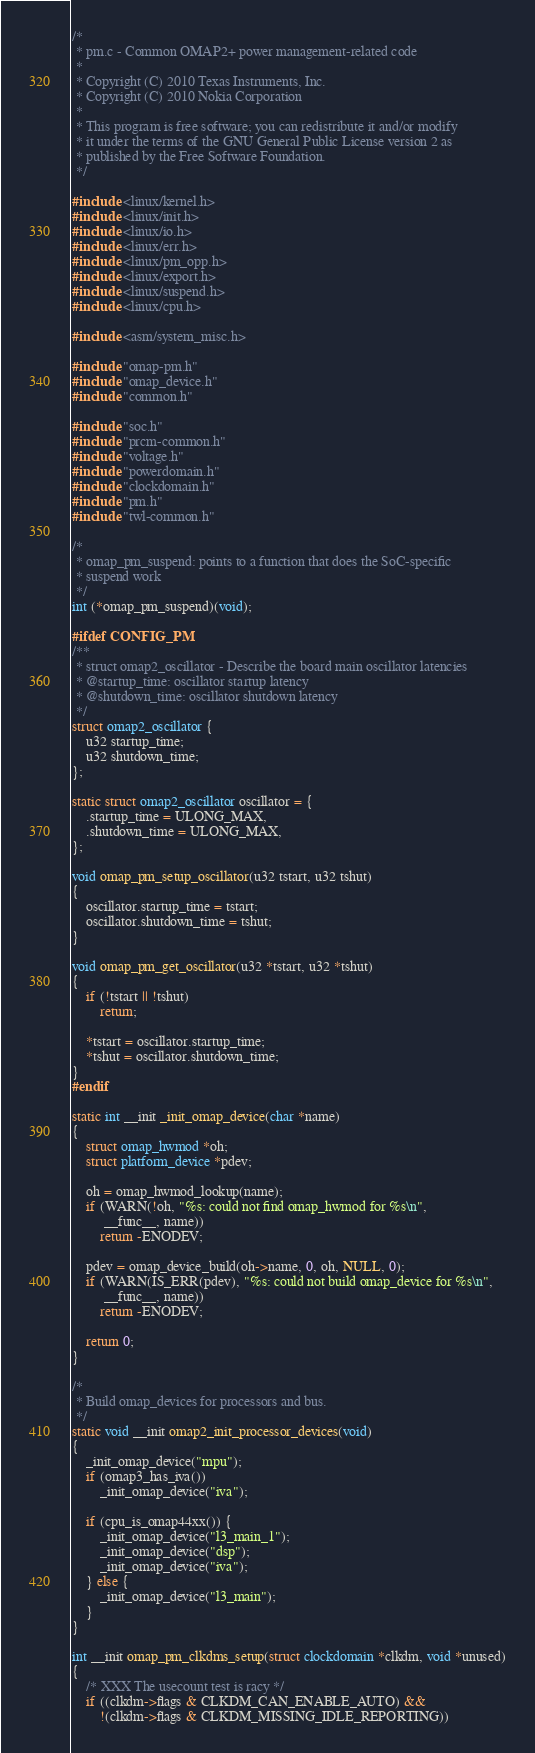Convert code to text. <code><loc_0><loc_0><loc_500><loc_500><_C_>/*
 * pm.c - Common OMAP2+ power management-related code
 *
 * Copyright (C) 2010 Texas Instruments, Inc.
 * Copyright (C) 2010 Nokia Corporation
 *
 * This program is free software; you can redistribute it and/or modify
 * it under the terms of the GNU General Public License version 2 as
 * published by the Free Software Foundation.
 */

#include <linux/kernel.h>
#include <linux/init.h>
#include <linux/io.h>
#include <linux/err.h>
#include <linux/pm_opp.h>
#include <linux/export.h>
#include <linux/suspend.h>
#include <linux/cpu.h>

#include <asm/system_misc.h>

#include "omap-pm.h"
#include "omap_device.h"
#include "common.h"

#include "soc.h"
#include "prcm-common.h"
#include "voltage.h"
#include "powerdomain.h"
#include "clockdomain.h"
#include "pm.h"
#include "twl-common.h"

/*
 * omap_pm_suspend: points to a function that does the SoC-specific
 * suspend work
 */
int (*omap_pm_suspend)(void);

#ifdef CONFIG_PM
/**
 * struct omap2_oscillator - Describe the board main oscillator latencies
 * @startup_time: oscillator startup latency
 * @shutdown_time: oscillator shutdown latency
 */
struct omap2_oscillator {
	u32 startup_time;
	u32 shutdown_time;
};

static struct omap2_oscillator oscillator = {
	.startup_time = ULONG_MAX,
	.shutdown_time = ULONG_MAX,
};

void omap_pm_setup_oscillator(u32 tstart, u32 tshut)
{
	oscillator.startup_time = tstart;
	oscillator.shutdown_time = tshut;
}

void omap_pm_get_oscillator(u32 *tstart, u32 *tshut)
{
	if (!tstart || !tshut)
		return;

	*tstart = oscillator.startup_time;
	*tshut = oscillator.shutdown_time;
}
#endif

static int __init _init_omap_device(char *name)
{
	struct omap_hwmod *oh;
	struct platform_device *pdev;

	oh = omap_hwmod_lookup(name);
	if (WARN(!oh, "%s: could not find omap_hwmod for %s\n",
		 __func__, name))
		return -ENODEV;

	pdev = omap_device_build(oh->name, 0, oh, NULL, 0);
	if (WARN(IS_ERR(pdev), "%s: could not build omap_device for %s\n",
		 __func__, name))
		return -ENODEV;

	return 0;
}

/*
 * Build omap_devices for processors and bus.
 */
static void __init omap2_init_processor_devices(void)
{
	_init_omap_device("mpu");
	if (omap3_has_iva())
		_init_omap_device("iva");

	if (cpu_is_omap44xx()) {
		_init_omap_device("l3_main_1");
		_init_omap_device("dsp");
		_init_omap_device("iva");
	} else {
		_init_omap_device("l3_main");
	}
}

int __init omap_pm_clkdms_setup(struct clockdomain *clkdm, void *unused)
{
	/* XXX The usecount test is racy */
	if ((clkdm->flags & CLKDM_CAN_ENABLE_AUTO) &&
	    !(clkdm->flags & CLKDM_MISSING_IDLE_REPORTING))</code> 